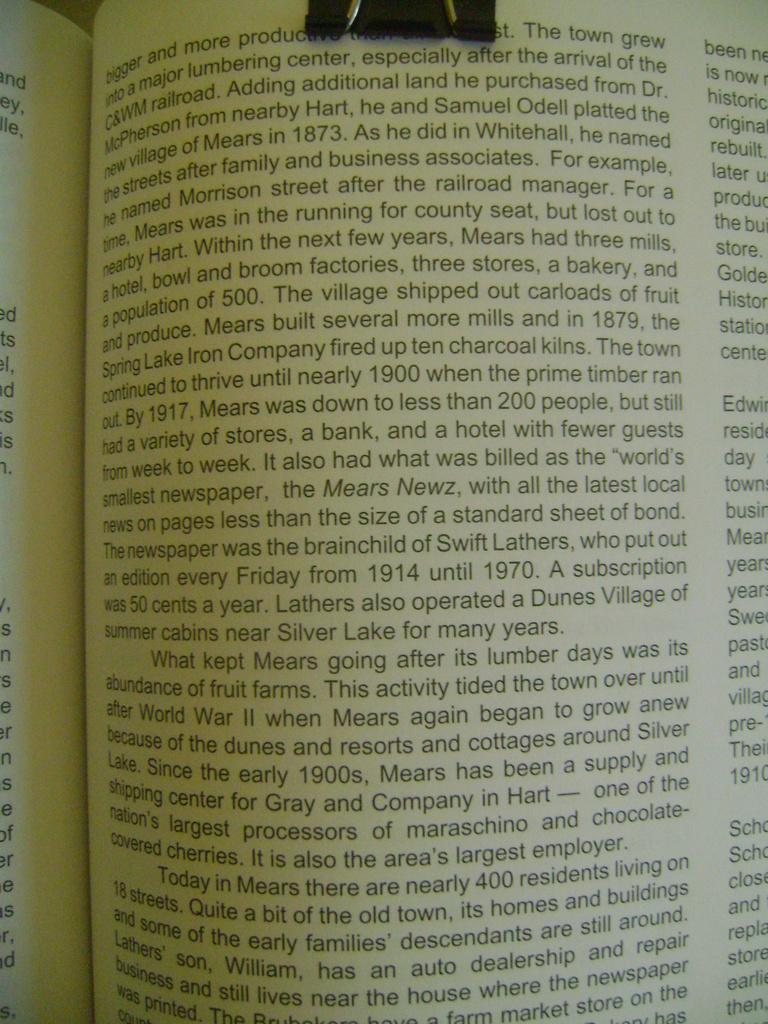<image>
Describe the image concisely. A book is open to a page with the first word being bigger. 